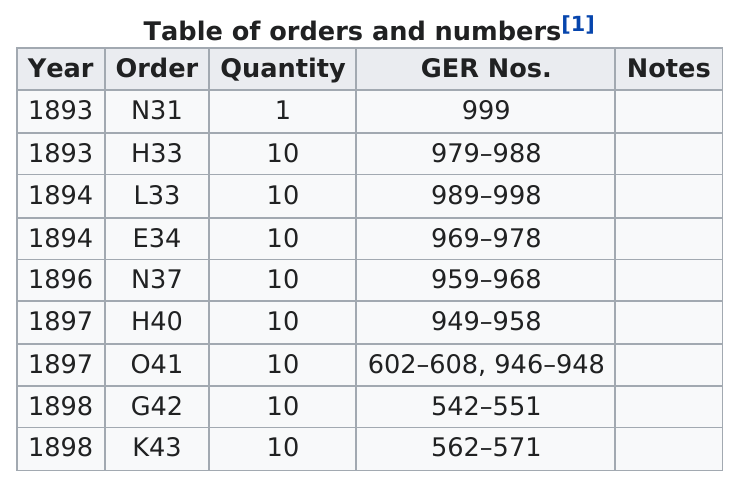Draw attention to some important aspects in this diagram. The last year listed in K43 is in order. The answer is: In 1898, there were more German numbers than in 1893. In the last 900 years, the number of men living below 900 has decreased by 2. In 1893, the number of German immigrants to the United States was the lowest among all years recorded. The last year listed is 1898. 